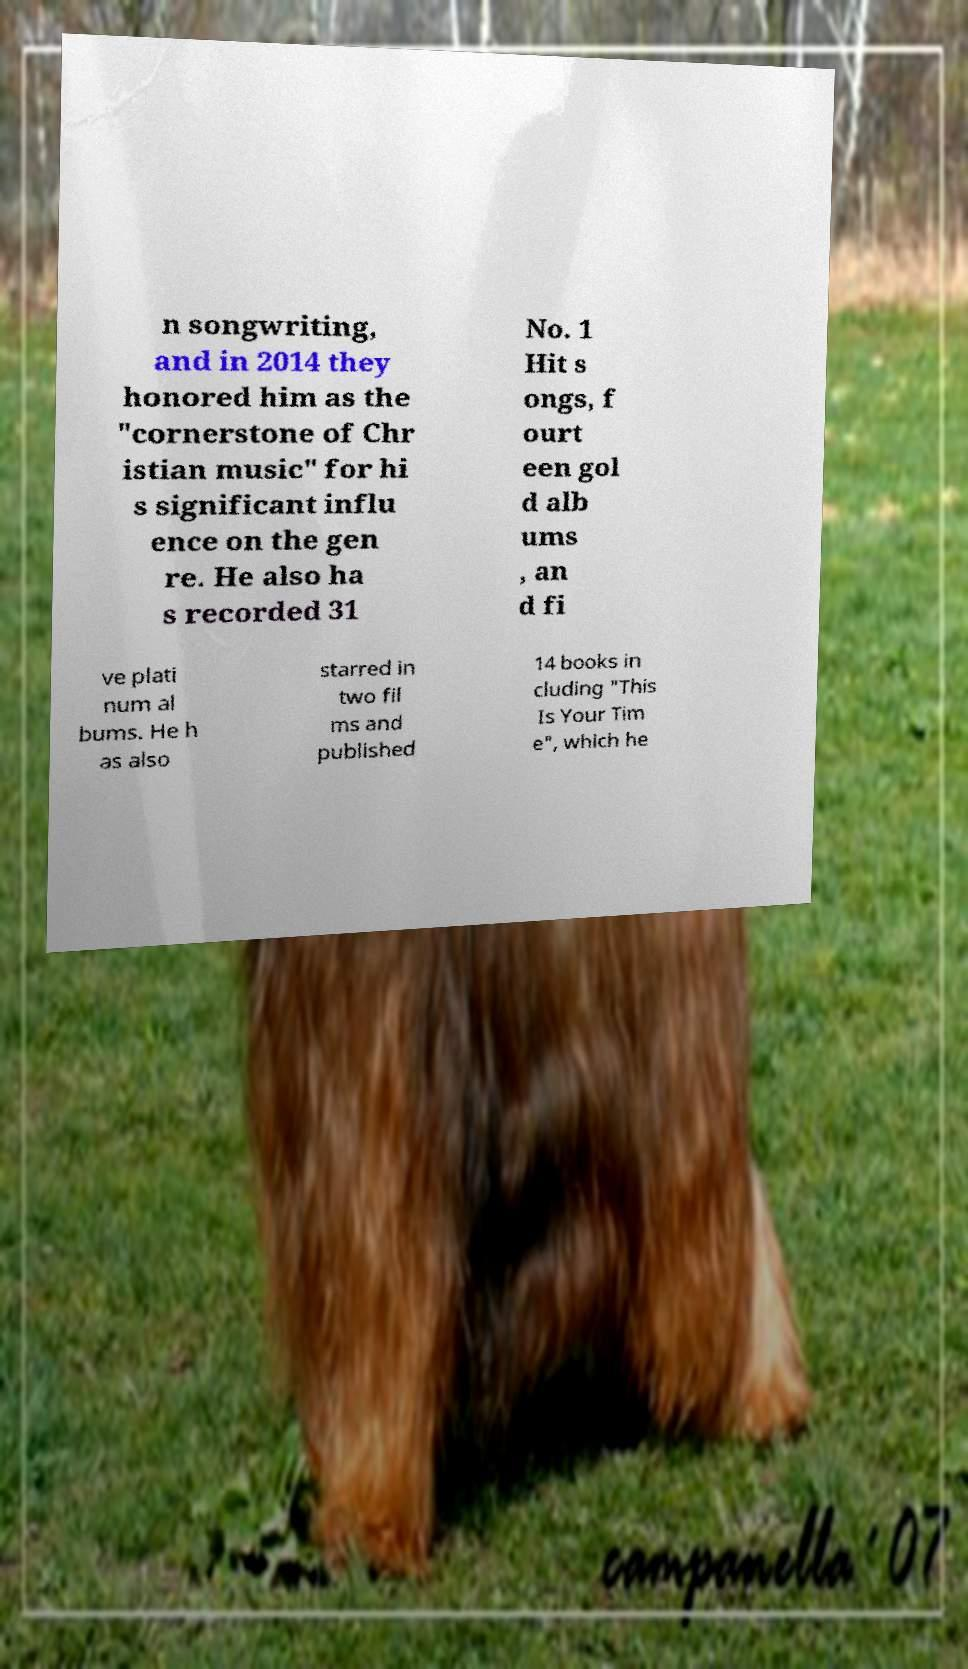Please read and relay the text visible in this image. What does it say? n songwriting, and in 2014 they honored him as the "cornerstone of Chr istian music" for hi s significant influ ence on the gen re. He also ha s recorded 31 No. 1 Hit s ongs, f ourt een gol d alb ums , an d fi ve plati num al bums. He h as also starred in two fil ms and published 14 books in cluding "This Is Your Tim e", which he 